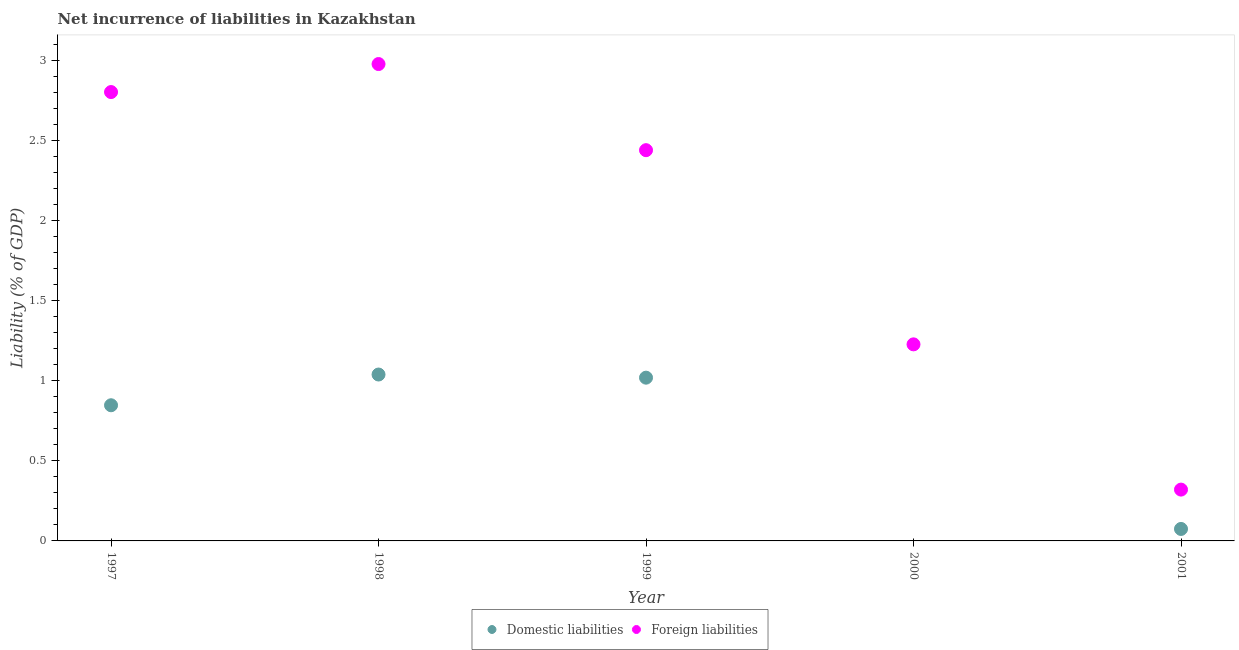How many different coloured dotlines are there?
Your answer should be very brief. 2. What is the incurrence of foreign liabilities in 2001?
Your answer should be compact. 0.32. Across all years, what is the maximum incurrence of domestic liabilities?
Ensure brevity in your answer.  1.04. In which year was the incurrence of foreign liabilities maximum?
Your answer should be compact. 1998. What is the total incurrence of foreign liabilities in the graph?
Make the answer very short. 9.76. What is the difference between the incurrence of foreign liabilities in 1998 and that in 2000?
Provide a succinct answer. 1.75. What is the difference between the incurrence of foreign liabilities in 2001 and the incurrence of domestic liabilities in 2000?
Your answer should be compact. 0.32. What is the average incurrence of domestic liabilities per year?
Give a very brief answer. 0.6. In the year 1997, what is the difference between the incurrence of domestic liabilities and incurrence of foreign liabilities?
Your answer should be compact. -1.95. What is the ratio of the incurrence of foreign liabilities in 1997 to that in 2001?
Provide a succinct answer. 8.75. What is the difference between the highest and the second highest incurrence of foreign liabilities?
Provide a short and direct response. 0.17. What is the difference between the highest and the lowest incurrence of domestic liabilities?
Your answer should be very brief. 1.04. In how many years, is the incurrence of foreign liabilities greater than the average incurrence of foreign liabilities taken over all years?
Your answer should be compact. 3. Is the sum of the incurrence of domestic liabilities in 1998 and 1999 greater than the maximum incurrence of foreign liabilities across all years?
Ensure brevity in your answer.  No. Does the incurrence of foreign liabilities monotonically increase over the years?
Make the answer very short. No. Is the incurrence of foreign liabilities strictly greater than the incurrence of domestic liabilities over the years?
Your answer should be very brief. Yes. Is the incurrence of domestic liabilities strictly less than the incurrence of foreign liabilities over the years?
Keep it short and to the point. Yes. How many dotlines are there?
Offer a terse response. 2. How many years are there in the graph?
Your answer should be very brief. 5. Are the values on the major ticks of Y-axis written in scientific E-notation?
Keep it short and to the point. No. Where does the legend appear in the graph?
Provide a short and direct response. Bottom center. How many legend labels are there?
Your answer should be very brief. 2. How are the legend labels stacked?
Give a very brief answer. Horizontal. What is the title of the graph?
Ensure brevity in your answer.  Net incurrence of liabilities in Kazakhstan. Does "Automatic Teller Machines" appear as one of the legend labels in the graph?
Give a very brief answer. No. What is the label or title of the Y-axis?
Keep it short and to the point. Liability (% of GDP). What is the Liability (% of GDP) of Domestic liabilities in 1997?
Your answer should be very brief. 0.85. What is the Liability (% of GDP) in Foreign liabilities in 1997?
Your answer should be very brief. 2.8. What is the Liability (% of GDP) of Domestic liabilities in 1998?
Your answer should be compact. 1.04. What is the Liability (% of GDP) of Foreign liabilities in 1998?
Ensure brevity in your answer.  2.98. What is the Liability (% of GDP) in Domestic liabilities in 1999?
Offer a terse response. 1.02. What is the Liability (% of GDP) of Foreign liabilities in 1999?
Ensure brevity in your answer.  2.44. What is the Liability (% of GDP) of Foreign liabilities in 2000?
Ensure brevity in your answer.  1.23. What is the Liability (% of GDP) in Domestic liabilities in 2001?
Keep it short and to the point. 0.07. What is the Liability (% of GDP) of Foreign liabilities in 2001?
Ensure brevity in your answer.  0.32. Across all years, what is the maximum Liability (% of GDP) in Domestic liabilities?
Your answer should be compact. 1.04. Across all years, what is the maximum Liability (% of GDP) of Foreign liabilities?
Your response must be concise. 2.98. Across all years, what is the minimum Liability (% of GDP) in Domestic liabilities?
Ensure brevity in your answer.  0. Across all years, what is the minimum Liability (% of GDP) in Foreign liabilities?
Give a very brief answer. 0.32. What is the total Liability (% of GDP) of Domestic liabilities in the graph?
Ensure brevity in your answer.  2.98. What is the total Liability (% of GDP) of Foreign liabilities in the graph?
Offer a terse response. 9.76. What is the difference between the Liability (% of GDP) in Domestic liabilities in 1997 and that in 1998?
Provide a succinct answer. -0.19. What is the difference between the Liability (% of GDP) in Foreign liabilities in 1997 and that in 1998?
Your answer should be compact. -0.17. What is the difference between the Liability (% of GDP) in Domestic liabilities in 1997 and that in 1999?
Provide a succinct answer. -0.17. What is the difference between the Liability (% of GDP) of Foreign liabilities in 1997 and that in 1999?
Your answer should be very brief. 0.36. What is the difference between the Liability (% of GDP) of Foreign liabilities in 1997 and that in 2000?
Provide a succinct answer. 1.57. What is the difference between the Liability (% of GDP) in Domestic liabilities in 1997 and that in 2001?
Offer a terse response. 0.77. What is the difference between the Liability (% of GDP) in Foreign liabilities in 1997 and that in 2001?
Give a very brief answer. 2.48. What is the difference between the Liability (% of GDP) of Domestic liabilities in 1998 and that in 1999?
Your answer should be very brief. 0.02. What is the difference between the Liability (% of GDP) of Foreign liabilities in 1998 and that in 1999?
Give a very brief answer. 0.54. What is the difference between the Liability (% of GDP) of Foreign liabilities in 1998 and that in 2000?
Provide a succinct answer. 1.75. What is the difference between the Liability (% of GDP) in Domestic liabilities in 1998 and that in 2001?
Your answer should be compact. 0.96. What is the difference between the Liability (% of GDP) of Foreign liabilities in 1998 and that in 2001?
Ensure brevity in your answer.  2.66. What is the difference between the Liability (% of GDP) in Foreign liabilities in 1999 and that in 2000?
Your answer should be very brief. 1.21. What is the difference between the Liability (% of GDP) in Domestic liabilities in 1999 and that in 2001?
Your answer should be compact. 0.94. What is the difference between the Liability (% of GDP) in Foreign liabilities in 1999 and that in 2001?
Your response must be concise. 2.12. What is the difference between the Liability (% of GDP) in Foreign liabilities in 2000 and that in 2001?
Provide a short and direct response. 0.91. What is the difference between the Liability (% of GDP) in Domestic liabilities in 1997 and the Liability (% of GDP) in Foreign liabilities in 1998?
Offer a very short reply. -2.13. What is the difference between the Liability (% of GDP) in Domestic liabilities in 1997 and the Liability (% of GDP) in Foreign liabilities in 1999?
Keep it short and to the point. -1.59. What is the difference between the Liability (% of GDP) of Domestic liabilities in 1997 and the Liability (% of GDP) of Foreign liabilities in 2000?
Provide a succinct answer. -0.38. What is the difference between the Liability (% of GDP) in Domestic liabilities in 1997 and the Liability (% of GDP) in Foreign liabilities in 2001?
Make the answer very short. 0.53. What is the difference between the Liability (% of GDP) of Domestic liabilities in 1998 and the Liability (% of GDP) of Foreign liabilities in 1999?
Provide a succinct answer. -1.4. What is the difference between the Liability (% of GDP) of Domestic liabilities in 1998 and the Liability (% of GDP) of Foreign liabilities in 2000?
Your answer should be compact. -0.19. What is the difference between the Liability (% of GDP) in Domestic liabilities in 1998 and the Liability (% of GDP) in Foreign liabilities in 2001?
Make the answer very short. 0.72. What is the difference between the Liability (% of GDP) of Domestic liabilities in 1999 and the Liability (% of GDP) of Foreign liabilities in 2000?
Offer a terse response. -0.21. What is the difference between the Liability (% of GDP) in Domestic liabilities in 1999 and the Liability (% of GDP) in Foreign liabilities in 2001?
Keep it short and to the point. 0.7. What is the average Liability (% of GDP) of Domestic liabilities per year?
Ensure brevity in your answer.  0.6. What is the average Liability (% of GDP) in Foreign liabilities per year?
Give a very brief answer. 1.95. In the year 1997, what is the difference between the Liability (% of GDP) of Domestic liabilities and Liability (% of GDP) of Foreign liabilities?
Ensure brevity in your answer.  -1.95. In the year 1998, what is the difference between the Liability (% of GDP) in Domestic liabilities and Liability (% of GDP) in Foreign liabilities?
Your response must be concise. -1.94. In the year 1999, what is the difference between the Liability (% of GDP) of Domestic liabilities and Liability (% of GDP) of Foreign liabilities?
Offer a very short reply. -1.42. In the year 2001, what is the difference between the Liability (% of GDP) of Domestic liabilities and Liability (% of GDP) of Foreign liabilities?
Ensure brevity in your answer.  -0.25. What is the ratio of the Liability (% of GDP) in Domestic liabilities in 1997 to that in 1998?
Make the answer very short. 0.82. What is the ratio of the Liability (% of GDP) of Foreign liabilities in 1997 to that in 1998?
Provide a short and direct response. 0.94. What is the ratio of the Liability (% of GDP) in Domestic liabilities in 1997 to that in 1999?
Your answer should be very brief. 0.83. What is the ratio of the Liability (% of GDP) of Foreign liabilities in 1997 to that in 1999?
Offer a terse response. 1.15. What is the ratio of the Liability (% of GDP) in Foreign liabilities in 1997 to that in 2000?
Make the answer very short. 2.28. What is the ratio of the Liability (% of GDP) of Domestic liabilities in 1997 to that in 2001?
Give a very brief answer. 11.33. What is the ratio of the Liability (% of GDP) in Foreign liabilities in 1997 to that in 2001?
Your answer should be very brief. 8.75. What is the ratio of the Liability (% of GDP) in Domestic liabilities in 1998 to that in 1999?
Offer a very short reply. 1.02. What is the ratio of the Liability (% of GDP) in Foreign liabilities in 1998 to that in 1999?
Keep it short and to the point. 1.22. What is the ratio of the Liability (% of GDP) in Foreign liabilities in 1998 to that in 2000?
Offer a very short reply. 2.43. What is the ratio of the Liability (% of GDP) in Domestic liabilities in 1998 to that in 2001?
Your response must be concise. 13.9. What is the ratio of the Liability (% of GDP) of Foreign liabilities in 1998 to that in 2001?
Offer a terse response. 9.29. What is the ratio of the Liability (% of GDP) in Foreign liabilities in 1999 to that in 2000?
Make the answer very short. 1.99. What is the ratio of the Liability (% of GDP) in Domestic liabilities in 1999 to that in 2001?
Offer a terse response. 13.64. What is the ratio of the Liability (% of GDP) in Foreign liabilities in 1999 to that in 2001?
Provide a succinct answer. 7.61. What is the ratio of the Liability (% of GDP) of Foreign liabilities in 2000 to that in 2001?
Provide a short and direct response. 3.83. What is the difference between the highest and the second highest Liability (% of GDP) in Domestic liabilities?
Your answer should be very brief. 0.02. What is the difference between the highest and the second highest Liability (% of GDP) in Foreign liabilities?
Make the answer very short. 0.17. What is the difference between the highest and the lowest Liability (% of GDP) of Domestic liabilities?
Your response must be concise. 1.04. What is the difference between the highest and the lowest Liability (% of GDP) of Foreign liabilities?
Provide a short and direct response. 2.66. 